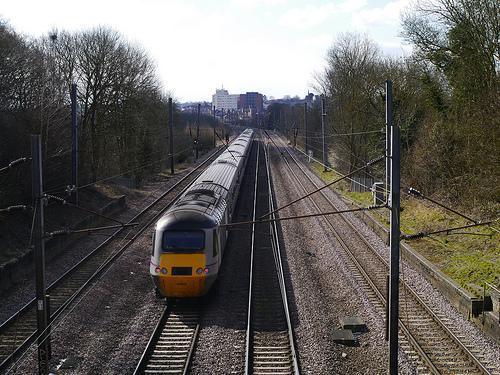How many trains are there?
Give a very brief answer. 1. 